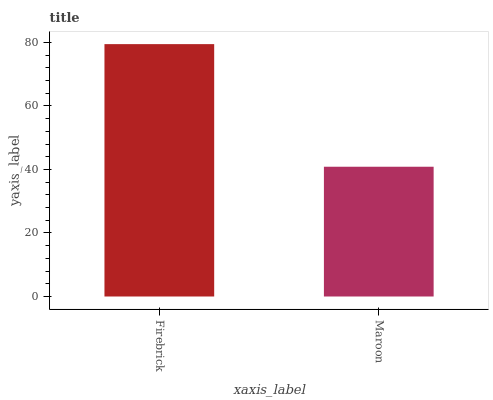Is Maroon the minimum?
Answer yes or no. Yes. Is Firebrick the maximum?
Answer yes or no. Yes. Is Maroon the maximum?
Answer yes or no. No. Is Firebrick greater than Maroon?
Answer yes or no. Yes. Is Maroon less than Firebrick?
Answer yes or no. Yes. Is Maroon greater than Firebrick?
Answer yes or no. No. Is Firebrick less than Maroon?
Answer yes or no. No. Is Firebrick the high median?
Answer yes or no. Yes. Is Maroon the low median?
Answer yes or no. Yes. Is Maroon the high median?
Answer yes or no. No. Is Firebrick the low median?
Answer yes or no. No. 